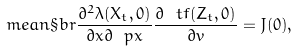Convert formula to latex. <formula><loc_0><loc_0><loc_500><loc_500>\ m e a n \S b r { \frac { \partial ^ { 2 } \lambda ( X _ { t } , 0 ) } { \partial x \partial \ p x } \frac { \partial \ t f ( Z _ { t } , 0 ) } { \partial v } } = J ( 0 ) ,</formula> 